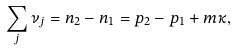<formula> <loc_0><loc_0><loc_500><loc_500>\sum _ { j } \nu _ { j } = n _ { 2 } - n _ { 1 } = p _ { 2 } - p _ { 1 } + m \kappa ,</formula> 